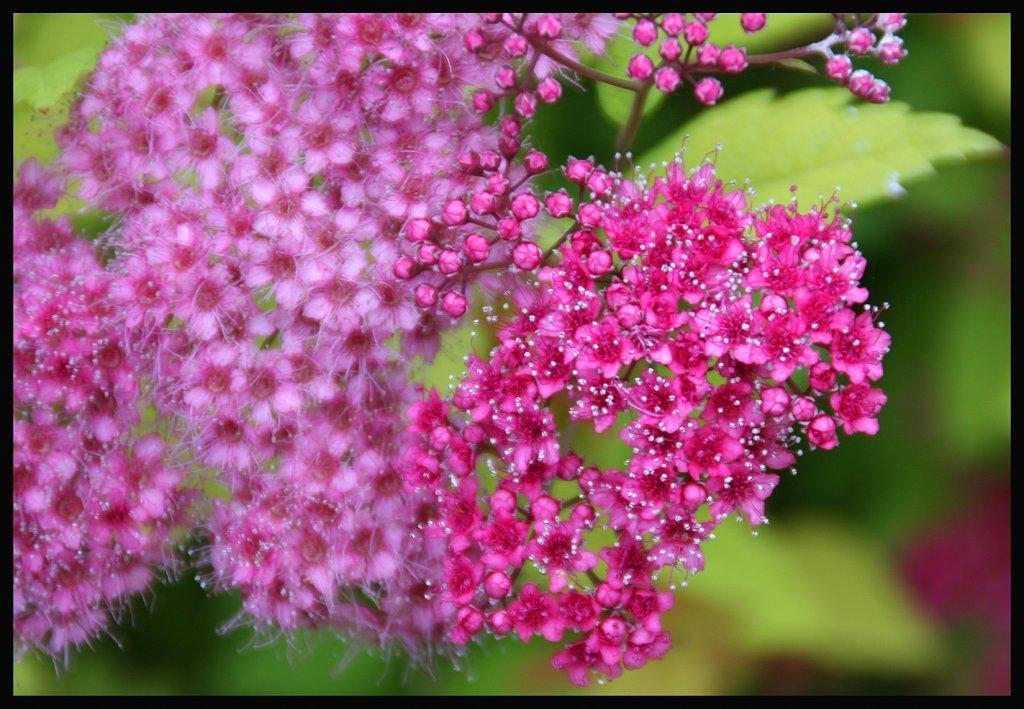What type of plants can be seen in the image? There are flowers and leaves in the image. Can you describe the background of the image? The background of the image is blurry. What type of meat is being prepared in the aftermath of the image? There is no meat or any indication of preparation in the image; it features flowers and leaves with a blurry background. 